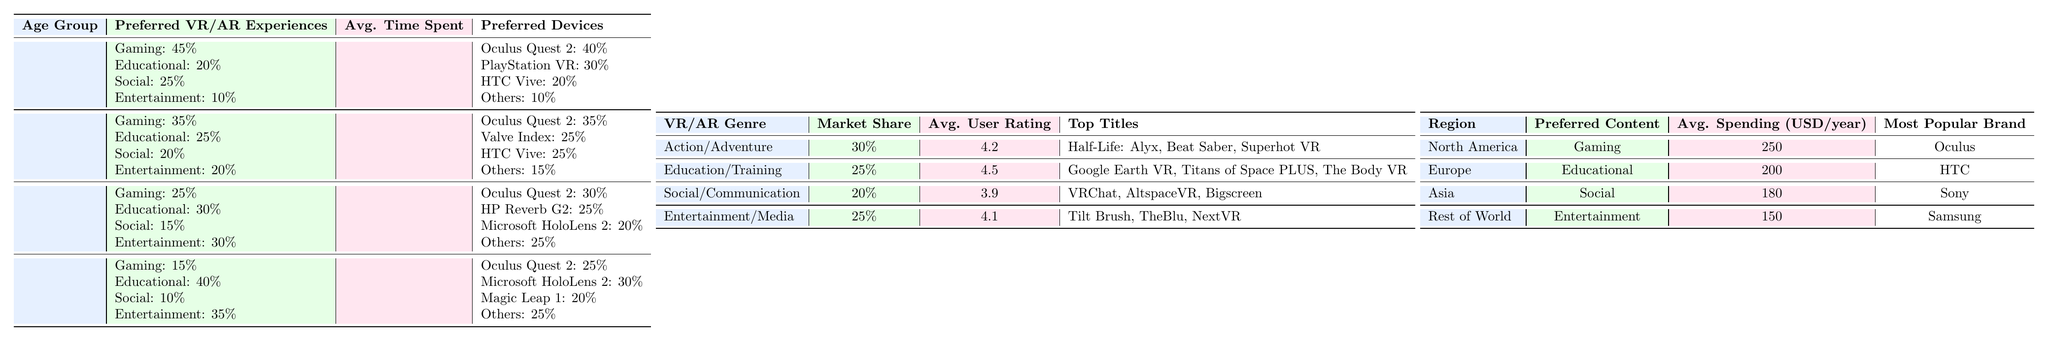What is the preferred VR/AR experience for the 45+ age group? According to the table, the preferred VR/AR experiences for the 45+ age group are Education (40%) and Entertainment (35%).
Answer: Educational and Entertainment What is the average time spent on VR/AR experiences by the 25-34 age group? The table shows that the average time spent on VR/AR experiences by the 25-34 age group is 6.2 hours per week.
Answer: 6.2 hours/week Which VR/AR genre has the highest market share? The genre with the highest market share is Action/Adventure, which has a market share of 30%.
Answer: Action/Adventure Which device is most preferred by users in the 18-24 age group? Based on the table, the most preferred device by users in the 18-24 age group is the Oculus Quest 2, with 40% preference.
Answer: Oculus Quest 2 What is the average spending in USD per year for users in Europe? The table indicates that the average spending for users in Europe is 200 USD per year.
Answer: 200 USD/year For the 35-44 age group, what is the difference in percentage preference between Educational and Entertainment experiences? For the 35-44 age group, the preference for Educational experiences is 30% and for Entertainment experiences is 30%. The difference is 0%.
Answer: 0% What percentage of users in the 45+ age group prefer Social experiences? According to the table, only 10% of users in the 45+ age group prefer Social experiences.
Answer: 10% Which region has the highest average spending on VR/AR experiences? The region with the highest average spending is North America, with an average spending of 250 USD per year.
Answer: North America How do the average time spent for the 35-44 age group compare to the 18-24 age group? The average time spent for the 35-44 age group is 5.1 hours/week, and for the 18-24 age group is 7.5 hours/week. The 35-44 age group spends 2.4 hours less per week.
Answer: 2.4 hours less Is the top title for Social/Communication the same as for Entertainment/Media? The top title for Social/Communication is VRChat, while the top title for Entertainment/Media is Tilt Brush. Since they are different, the answer is no.
Answer: No What is the total market share percentage for the Education/Training and Entertainment/Media genres combined? The market share for Education/Training is 25% and for Entertainment/Media is 25%. Combined, they total 50%.
Answer: 50% Which age group has the highest preference for Gaming experiences? The highest preference for Gaming experiences is found in the 18-24 age group, with a preference of 45%.
Answer: 18-24 age group 